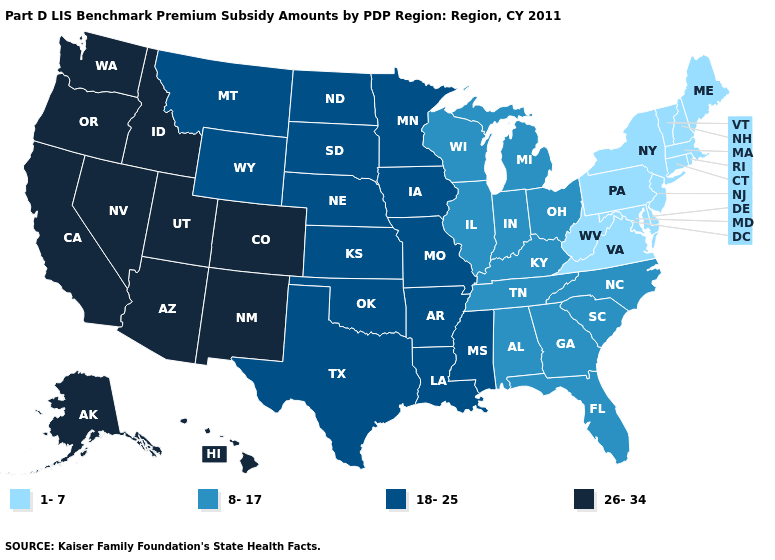Does Idaho have the same value as New Mexico?
Quick response, please. Yes. What is the highest value in the South ?
Quick response, please. 18-25. What is the value of Kansas?
Write a very short answer. 18-25. Name the states that have a value in the range 8-17?
Be succinct. Alabama, Florida, Georgia, Illinois, Indiana, Kentucky, Michigan, North Carolina, Ohio, South Carolina, Tennessee, Wisconsin. What is the lowest value in states that border Louisiana?
Write a very short answer. 18-25. Which states have the lowest value in the USA?
Concise answer only. Connecticut, Delaware, Maine, Maryland, Massachusetts, New Hampshire, New Jersey, New York, Pennsylvania, Rhode Island, Vermont, Virginia, West Virginia. What is the lowest value in states that border Nevada?
Give a very brief answer. 26-34. What is the value of Florida?
Be succinct. 8-17. Does the first symbol in the legend represent the smallest category?
Be succinct. Yes. Does Nebraska have the same value as Iowa?
Answer briefly. Yes. What is the value of Missouri?
Write a very short answer. 18-25. Does Oregon have the same value as Iowa?
Keep it brief. No. Among the states that border Wisconsin , does Minnesota have the lowest value?
Keep it brief. No. Does Ohio have a higher value than Arizona?
Be succinct. No. What is the value of Alaska?
Write a very short answer. 26-34. 